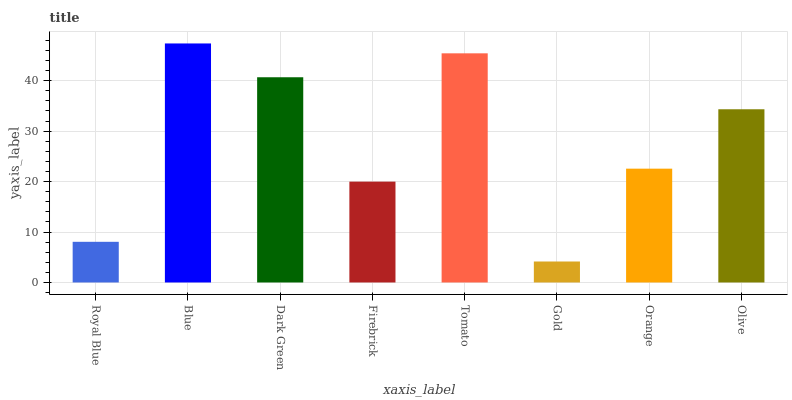Is Gold the minimum?
Answer yes or no. Yes. Is Blue the maximum?
Answer yes or no. Yes. Is Dark Green the minimum?
Answer yes or no. No. Is Dark Green the maximum?
Answer yes or no. No. Is Blue greater than Dark Green?
Answer yes or no. Yes. Is Dark Green less than Blue?
Answer yes or no. Yes. Is Dark Green greater than Blue?
Answer yes or no. No. Is Blue less than Dark Green?
Answer yes or no. No. Is Olive the high median?
Answer yes or no. Yes. Is Orange the low median?
Answer yes or no. Yes. Is Dark Green the high median?
Answer yes or no. No. Is Gold the low median?
Answer yes or no. No. 